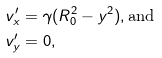<formula> <loc_0><loc_0><loc_500><loc_500>v _ { x } ^ { \prime } & = \gamma ( R _ { 0 } ^ { 2 } - y ^ { 2 } ) , \text {and} \\ v _ { y } ^ { \prime } & = 0 ,</formula> 